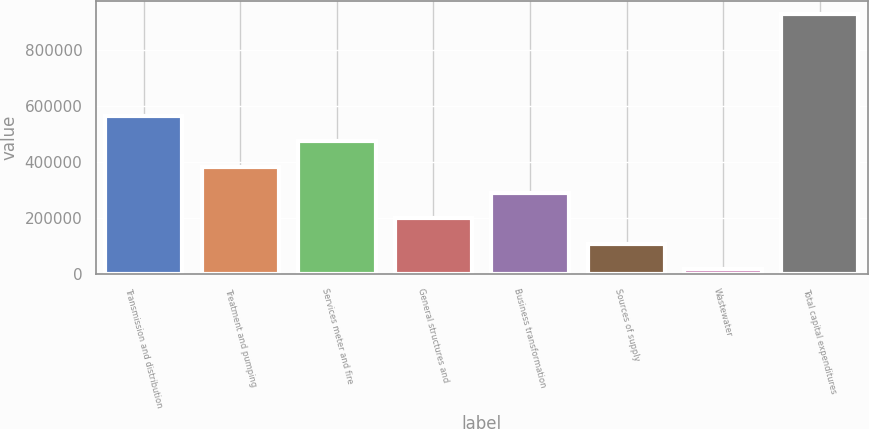Convert chart to OTSL. <chart><loc_0><loc_0><loc_500><loc_500><bar_chart><fcel>Transmission and distribution<fcel>Treatment and pumping<fcel>Services meter and fire<fcel>General structures and<fcel>Business transformation<fcel>Sources of supply<fcel>Wastewater<fcel>Total capital expenditures<nl><fcel>564545<fcel>382531<fcel>473538<fcel>200516<fcel>291524<fcel>109509<fcel>18502<fcel>928574<nl></chart> 